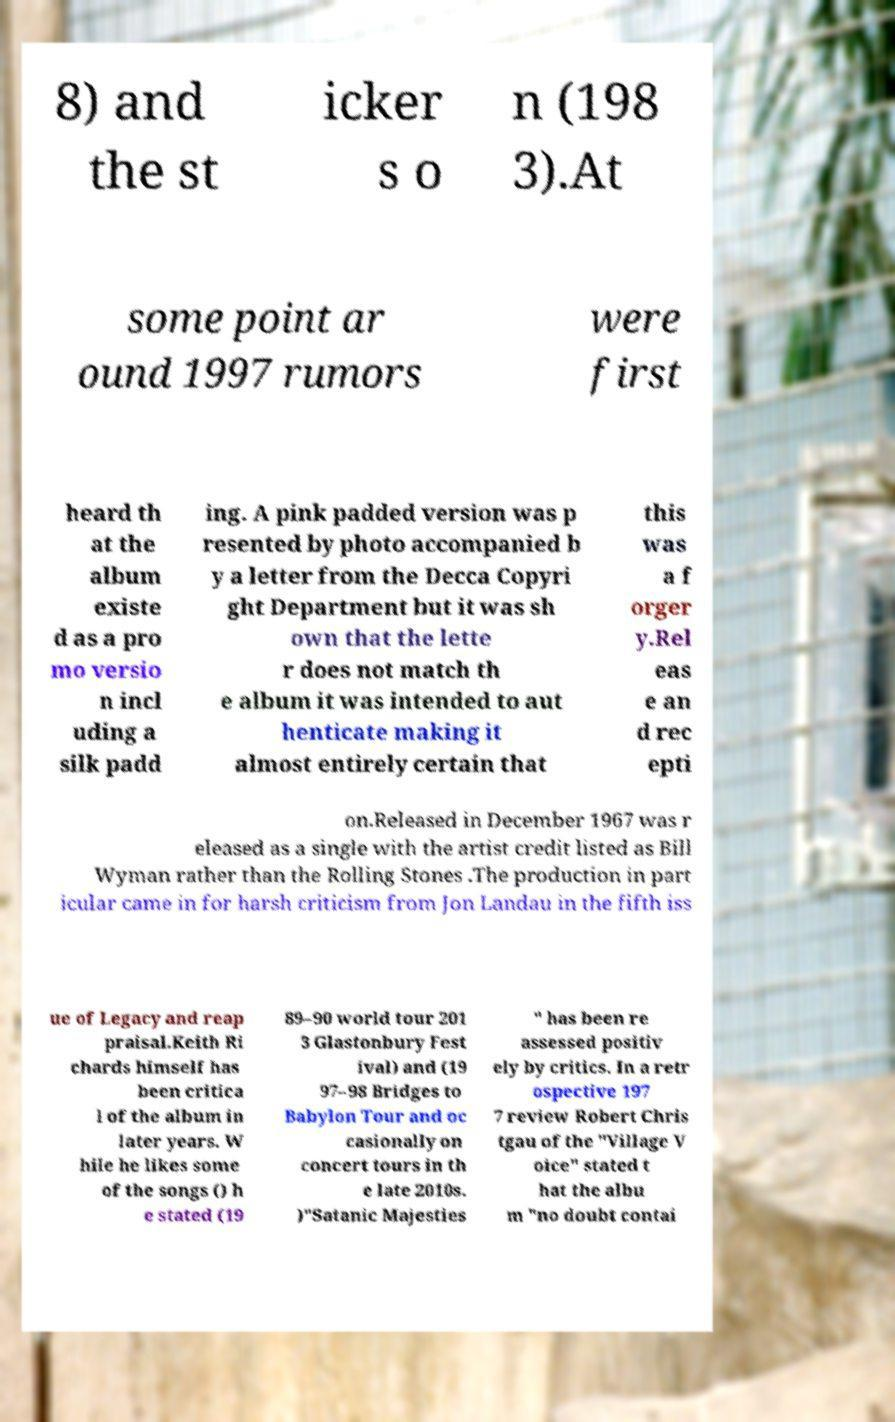What messages or text are displayed in this image? I need them in a readable, typed format. 8) and the st icker s o n (198 3).At some point ar ound 1997 rumors were first heard th at the album existe d as a pro mo versio n incl uding a silk padd ing. A pink padded version was p resented by photo accompanied b y a letter from the Decca Copyri ght Department but it was sh own that the lette r does not match th e album it was intended to aut henticate making it almost entirely certain that this was a f orger y.Rel eas e an d rec epti on.Released in December 1967 was r eleased as a single with the artist credit listed as Bill Wyman rather than the Rolling Stones .The production in part icular came in for harsh criticism from Jon Landau in the fifth iss ue of Legacy and reap praisal.Keith Ri chards himself has been critica l of the album in later years. W hile he likes some of the songs () h e stated (19 89–90 world tour 201 3 Glastonbury Fest ival) and (19 97–98 Bridges to Babylon Tour and oc casionally on concert tours in th e late 2010s. )"Satanic Majesties " has been re assessed positiv ely by critics. In a retr ospective 197 7 review Robert Chris tgau of the "Village V oice" stated t hat the albu m "no doubt contai 